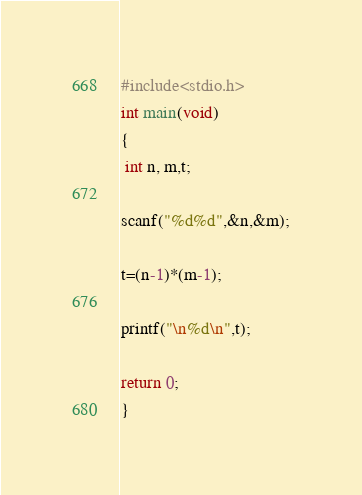Convert code to text. <code><loc_0><loc_0><loc_500><loc_500><_C_>#include<stdio.h>
int main(void)
{
 int n, m,t;

scanf("%d%d",&n,&m);

t=(n-1)*(m-1);

printf("\n%d\n",t);

return 0;
}</code> 